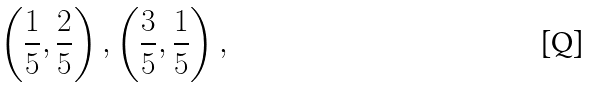Convert formula to latex. <formula><loc_0><loc_0><loc_500><loc_500>\left ( \frac { 1 } { 5 } , \frac { 2 } { 5 } \right ) , \left ( \frac { 3 } { 5 } , \frac { 1 } { 5 } \right ) ,</formula> 